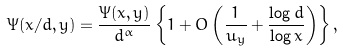<formula> <loc_0><loc_0><loc_500><loc_500>\Psi ( x / d , y ) = \frac { \Psi ( x , y ) } { d ^ { \alpha } } \left \{ 1 + O \left ( \frac { 1 } { u _ { y } } + \frac { \log d } { \log x } \right ) \right \} ,</formula> 